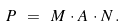<formula> <loc_0><loc_0><loc_500><loc_500>P \ = \ M \, \cdot \, A \, \cdot \, N \, .</formula> 